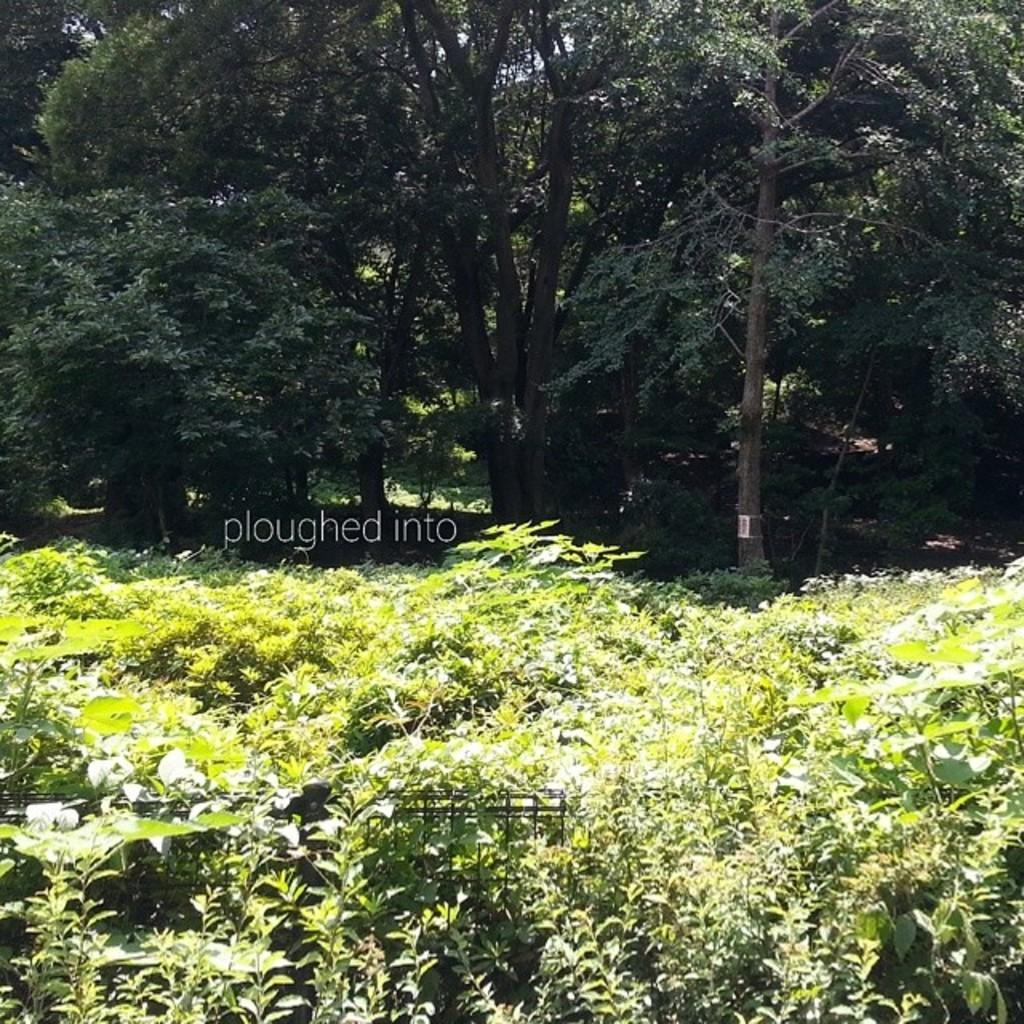What type of barrier can be seen in the image? There is a fence in the image. What type of vegetation is present in the image? There is grass, plants, and trees in the image. What can be found written or printed in the image? There is text in the image. What is the time of day when the image was likely taken? The image was likely taken during the day, as there is no indication of darkness or artificial lighting. Can you see any pins holding the text in the image? There are no pins visible in the image. Are there any toes visible in the image? There are no toes present in the image. 